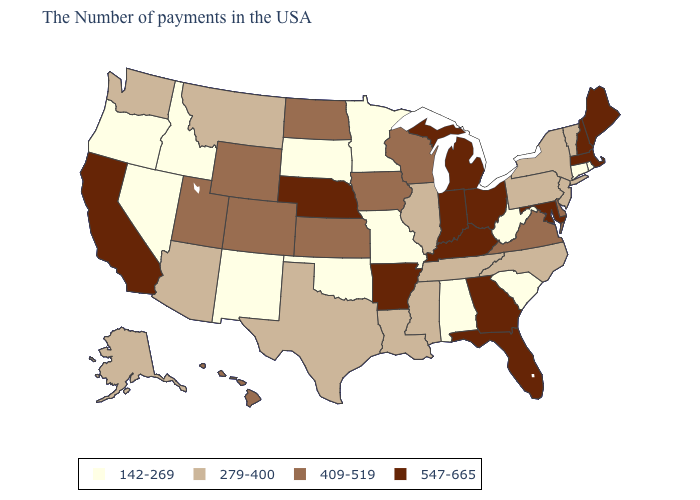Name the states that have a value in the range 409-519?
Be succinct. Delaware, Virginia, Wisconsin, Iowa, Kansas, North Dakota, Wyoming, Colorado, Utah, Hawaii. What is the highest value in the USA?
Be succinct. 547-665. What is the value of Wisconsin?
Short answer required. 409-519. How many symbols are there in the legend?
Give a very brief answer. 4. Does Texas have the lowest value in the USA?
Short answer required. No. Among the states that border Ohio , which have the highest value?
Quick response, please. Michigan, Kentucky, Indiana. Which states have the lowest value in the USA?
Be succinct. Rhode Island, Connecticut, South Carolina, West Virginia, Alabama, Missouri, Minnesota, Oklahoma, South Dakota, New Mexico, Idaho, Nevada, Oregon. What is the highest value in the USA?
Quick response, please. 547-665. What is the value of New Jersey?
Write a very short answer. 279-400. What is the lowest value in the USA?
Answer briefly. 142-269. What is the value of North Dakota?
Short answer required. 409-519. Which states have the lowest value in the USA?
Answer briefly. Rhode Island, Connecticut, South Carolina, West Virginia, Alabama, Missouri, Minnesota, Oklahoma, South Dakota, New Mexico, Idaho, Nevada, Oregon. Does the first symbol in the legend represent the smallest category?
Write a very short answer. Yes. Name the states that have a value in the range 142-269?
Be succinct. Rhode Island, Connecticut, South Carolina, West Virginia, Alabama, Missouri, Minnesota, Oklahoma, South Dakota, New Mexico, Idaho, Nevada, Oregon. Does Alabama have the lowest value in the South?
Keep it brief. Yes. 